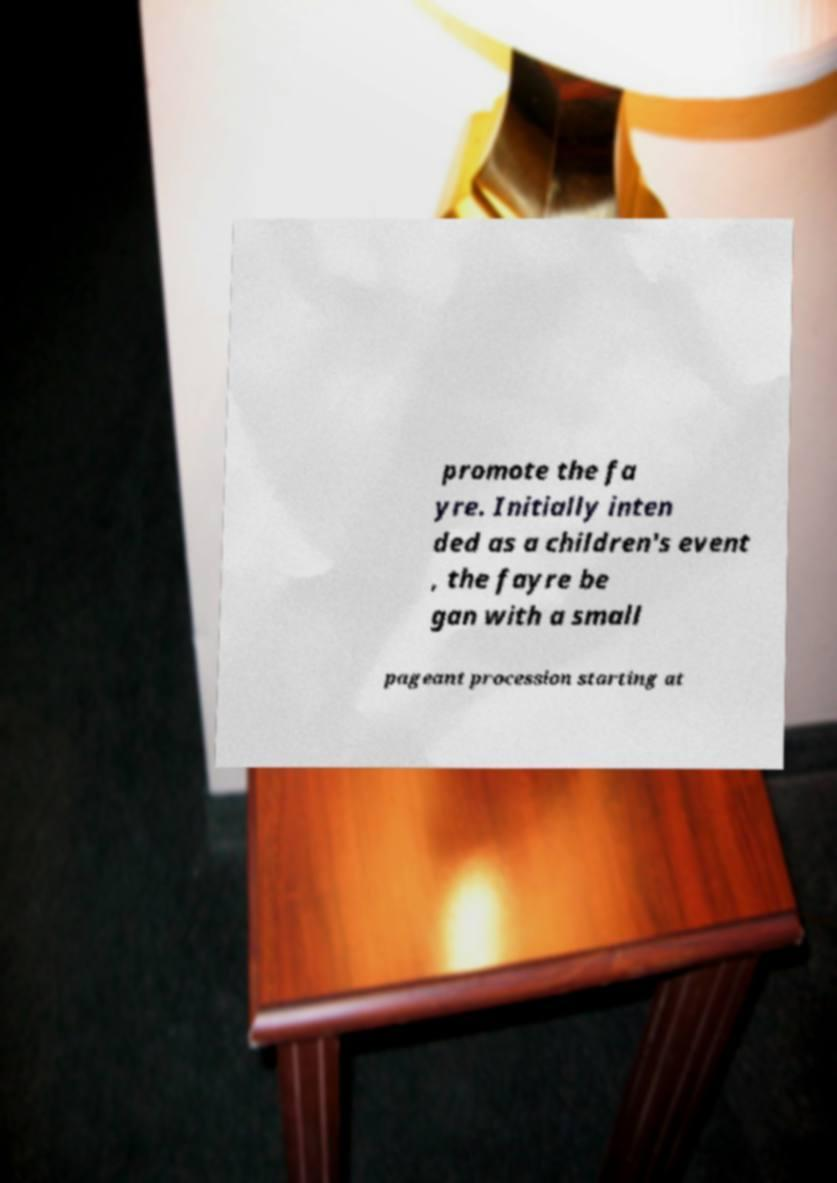There's text embedded in this image that I need extracted. Can you transcribe it verbatim? promote the fa yre. Initially inten ded as a children's event , the fayre be gan with a small pageant procession starting at 